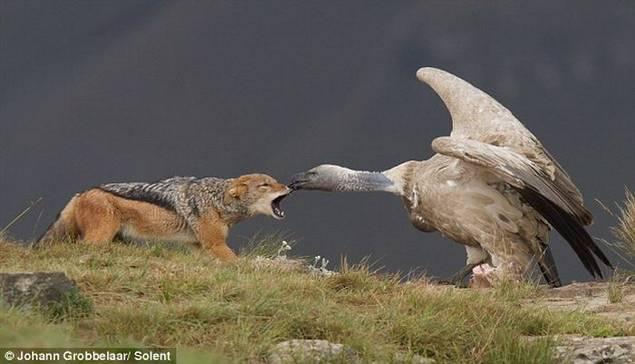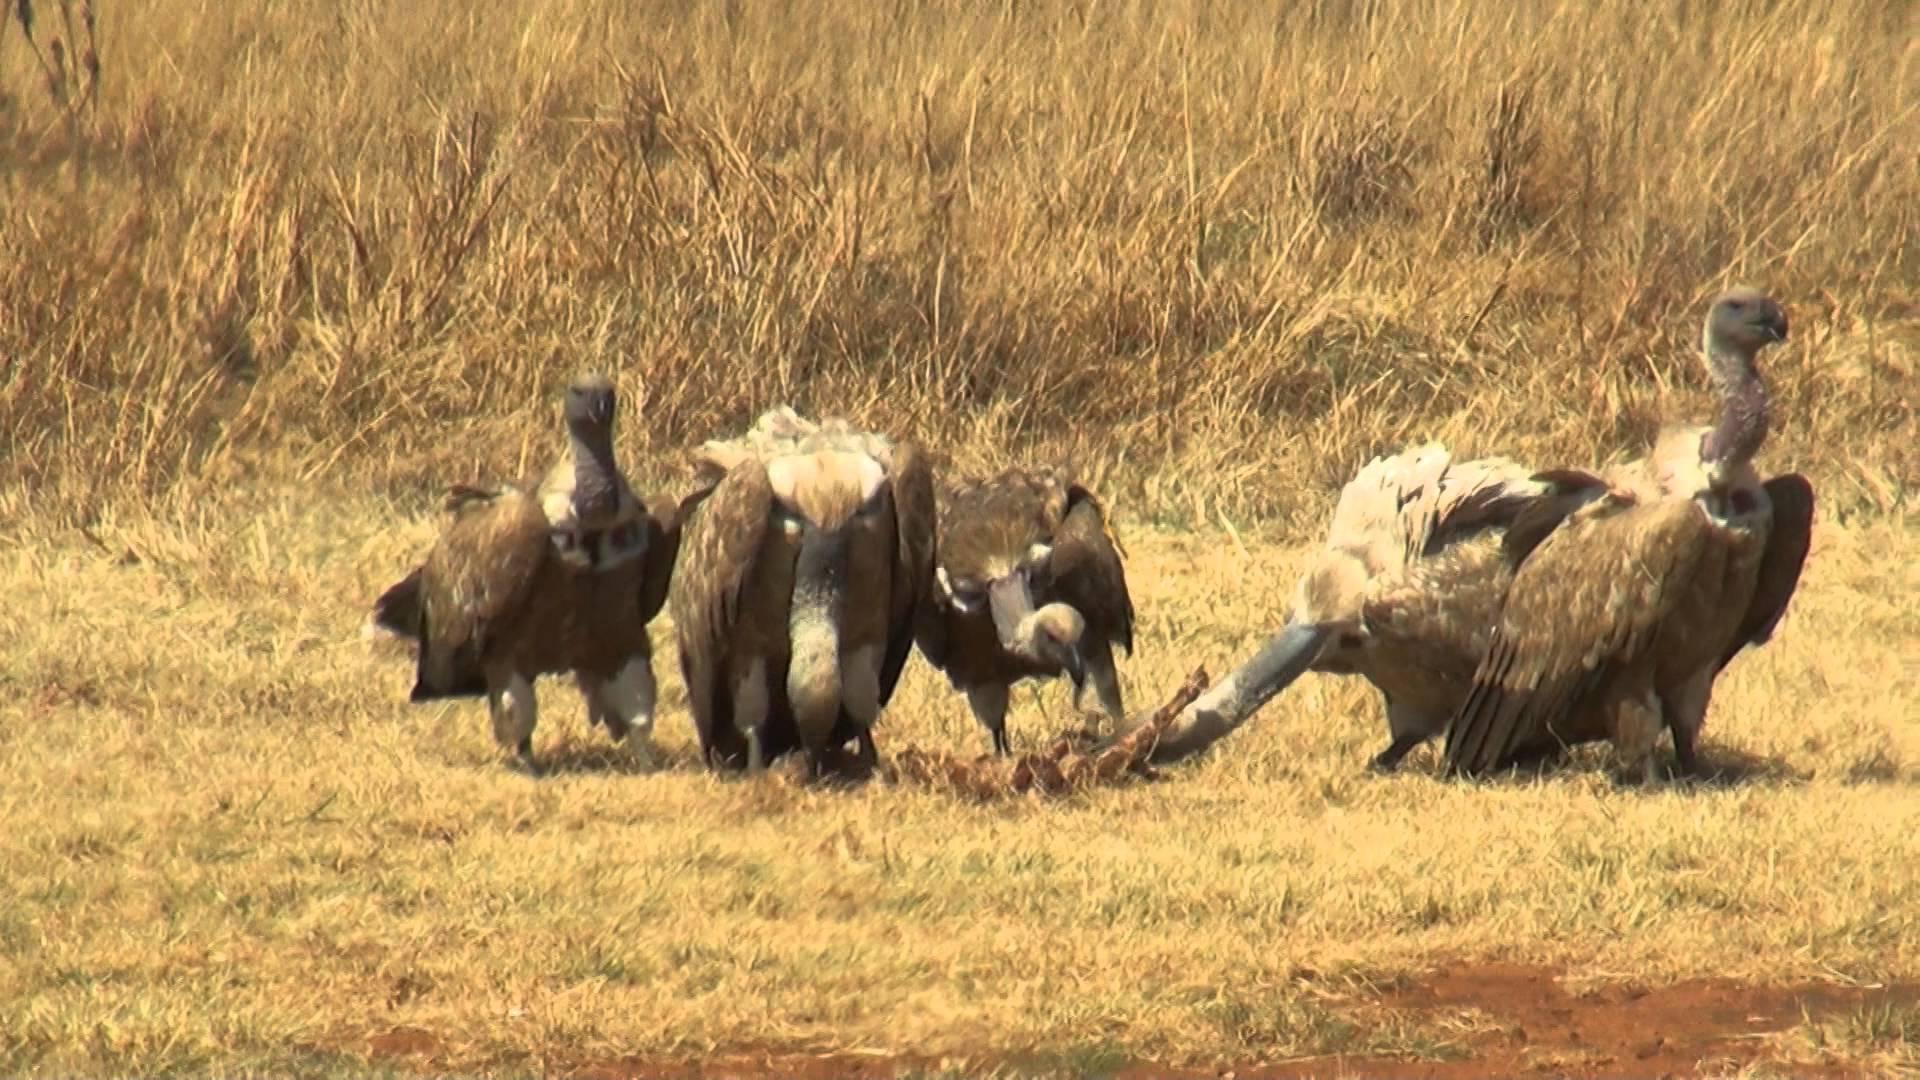The first image is the image on the left, the second image is the image on the right. For the images shown, is this caption "A vulture is face-to-face with a jackal standing in profile on all fours, in one image." true? Answer yes or no. Yes. 